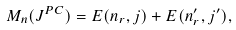Convert formula to latex. <formula><loc_0><loc_0><loc_500><loc_500>\ M _ { n } ( J ^ { P C } ) = E ( n _ { r } , j ) + E ( n ^ { \prime } _ { r } , j ^ { \prime } ) ,</formula> 